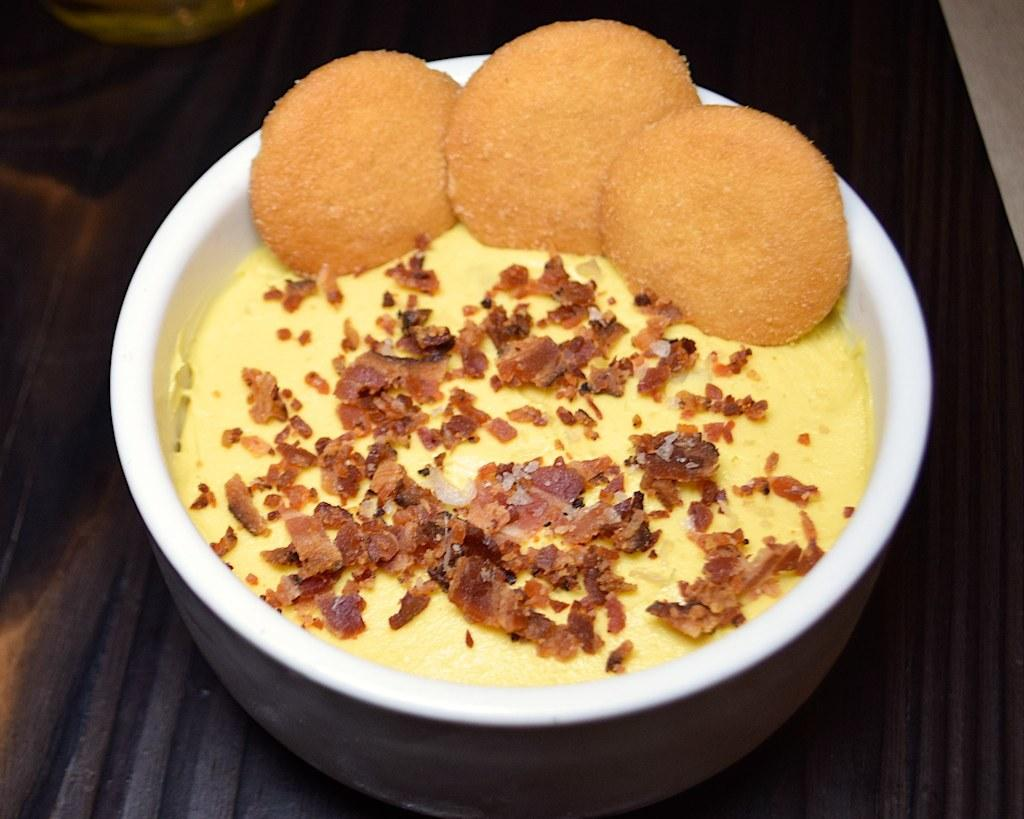What is on the table in the image? There is a bowl on the table in the image. What is inside the bowl? There is food in the bowl. How many lizards can be seen quietly hiding in the cellar in the image? There are no lizards or cellars present in the image. 